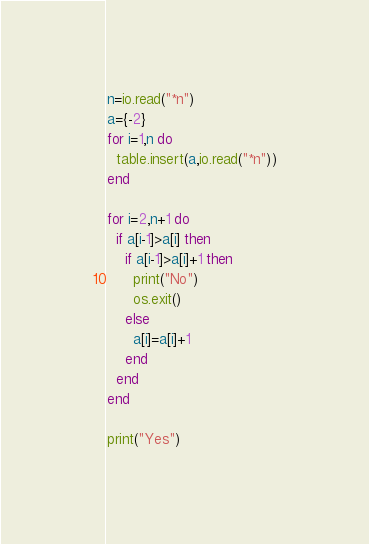Convert code to text. <code><loc_0><loc_0><loc_500><loc_500><_Lua_>n=io.read("*n")
a={-2}
for i=1,n do
  table.insert(a,io.read("*n"))
end

for i=2,n+1 do
  if a[i-1]>a[i] then
    if a[i-1]>a[i]+1 then
      print("No")
      os.exit()
    else
      a[i]=a[i]+1
    end
  end
end

print("Yes")</code> 